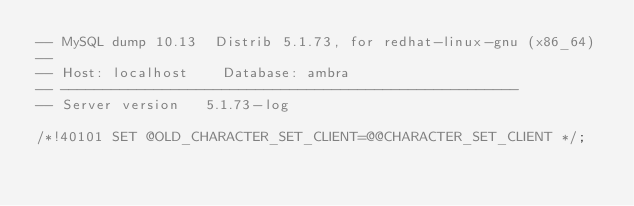<code> <loc_0><loc_0><loc_500><loc_500><_SQL_>-- MySQL dump 10.13  Distrib 5.1.73, for redhat-linux-gnu (x86_64)
--
-- Host: localhost    Database: ambra
-- ------------------------------------------------------
-- Server version	5.1.73-log

/*!40101 SET @OLD_CHARACTER_SET_CLIENT=@@CHARACTER_SET_CLIENT */;</code> 